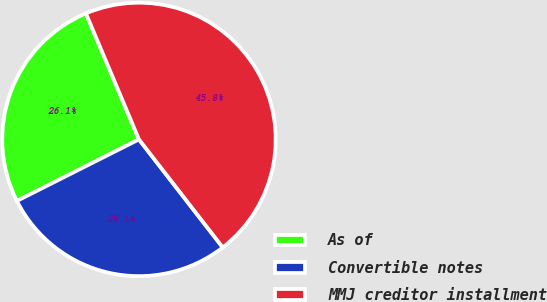Convert chart to OTSL. <chart><loc_0><loc_0><loc_500><loc_500><pie_chart><fcel>As of<fcel>Convertible notes<fcel>MMJ creditor installment<nl><fcel>26.09%<fcel>28.07%<fcel>45.84%<nl></chart> 